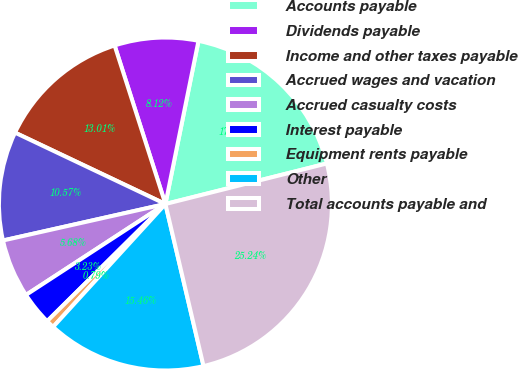Convert chart to OTSL. <chart><loc_0><loc_0><loc_500><loc_500><pie_chart><fcel>Accounts payable<fcel>Dividends payable<fcel>Income and other taxes payable<fcel>Accrued wages and vacation<fcel>Accrued casualty costs<fcel>Interest payable<fcel>Equipment rents payable<fcel>Other<fcel>Total accounts payable and<nl><fcel>17.9%<fcel>8.12%<fcel>13.01%<fcel>10.57%<fcel>5.68%<fcel>3.23%<fcel>0.79%<fcel>15.46%<fcel>25.24%<nl></chart> 